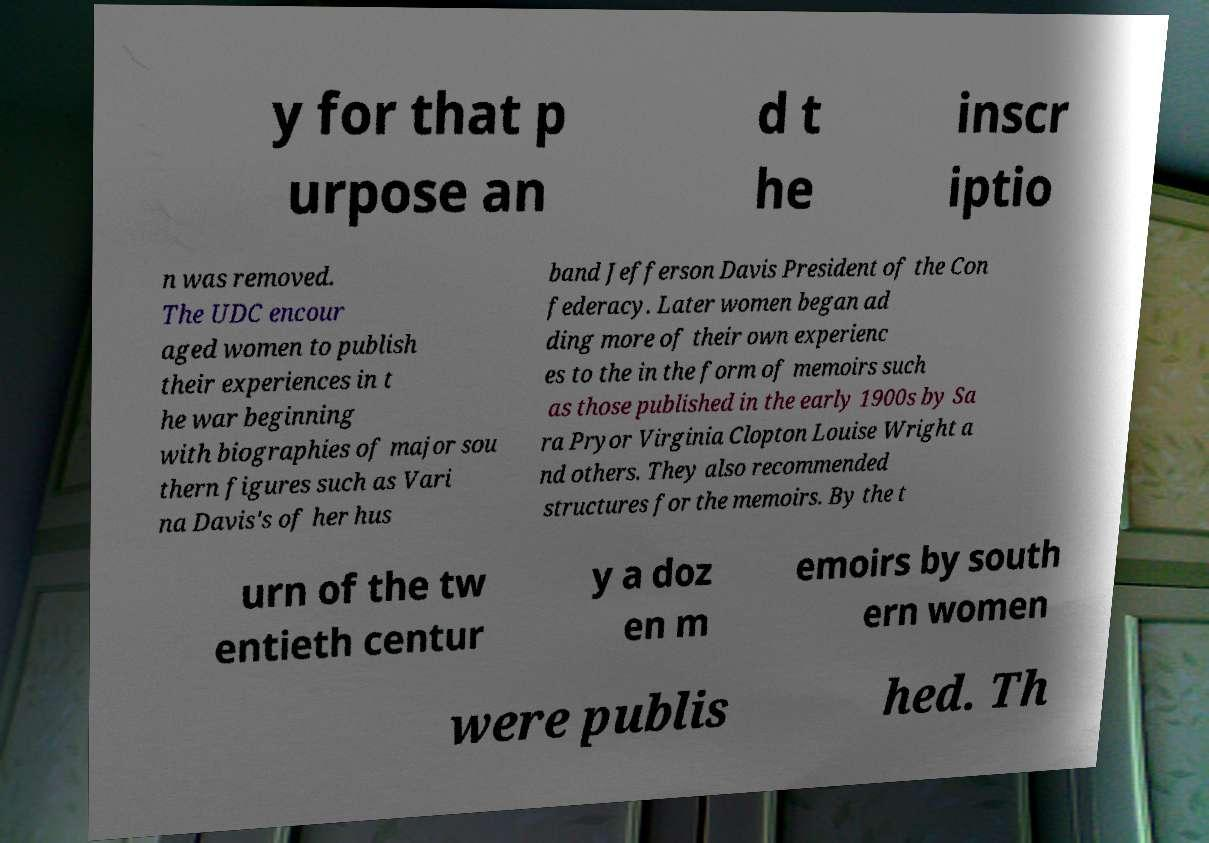Can you accurately transcribe the text from the provided image for me? y for that p urpose an d t he inscr iptio n was removed. The UDC encour aged women to publish their experiences in t he war beginning with biographies of major sou thern figures such as Vari na Davis's of her hus band Jefferson Davis President of the Con federacy. Later women began ad ding more of their own experienc es to the in the form of memoirs such as those published in the early 1900s by Sa ra Pryor Virginia Clopton Louise Wright a nd others. They also recommended structures for the memoirs. By the t urn of the tw entieth centur y a doz en m emoirs by south ern women were publis hed. Th 